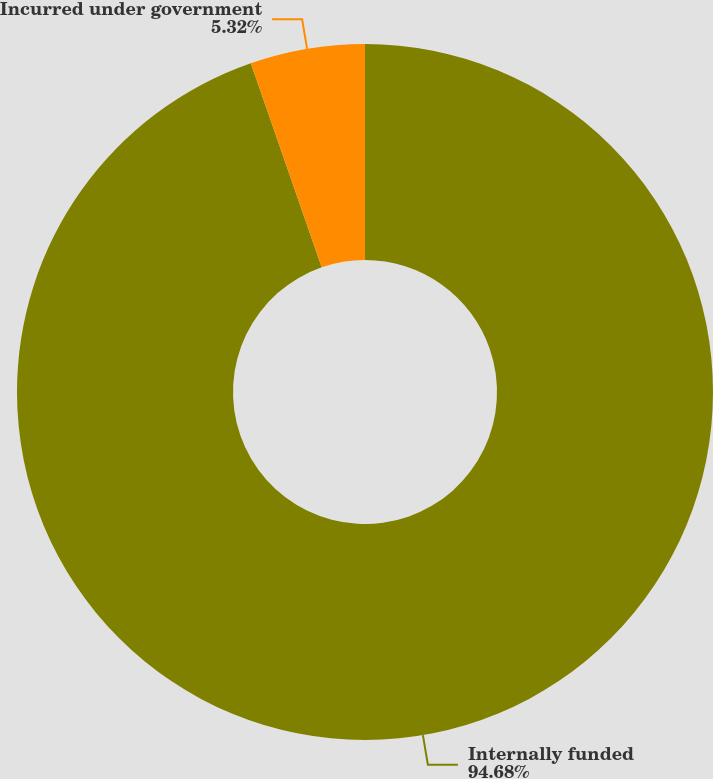Convert chart. <chart><loc_0><loc_0><loc_500><loc_500><pie_chart><fcel>Internally funded<fcel>Incurred under government<nl><fcel>94.68%<fcel>5.32%<nl></chart> 